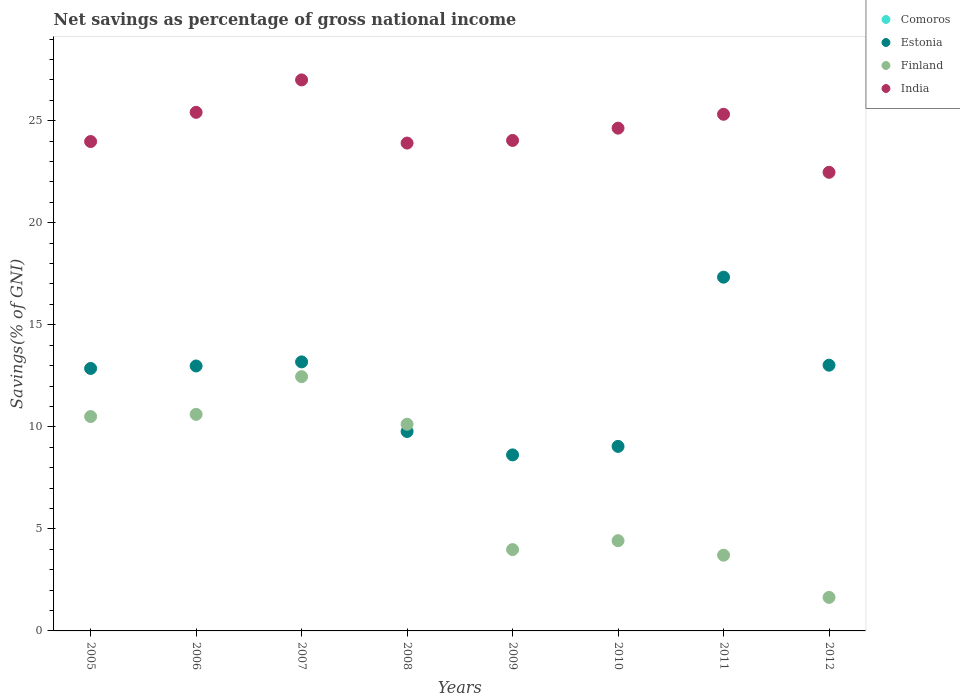How many different coloured dotlines are there?
Offer a very short reply. 3. What is the total savings in Finland in 2010?
Provide a short and direct response. 4.42. Across all years, what is the maximum total savings in Finland?
Your answer should be compact. 12.46. Across all years, what is the minimum total savings in Estonia?
Make the answer very short. 8.63. What is the total total savings in Estonia in the graph?
Give a very brief answer. 96.83. What is the difference between the total savings in India in 2005 and that in 2010?
Provide a short and direct response. -0.66. What is the difference between the total savings in Finland in 2011 and the total savings in Comoros in 2012?
Keep it short and to the point. 3.71. What is the average total savings in India per year?
Your answer should be compact. 24.6. In the year 2007, what is the difference between the total savings in Finland and total savings in India?
Your answer should be compact. -14.54. What is the ratio of the total savings in Finland in 2006 to that in 2009?
Your answer should be very brief. 2.66. Is the total savings in India in 2005 less than that in 2012?
Your answer should be compact. No. Is the difference between the total savings in Finland in 2006 and 2008 greater than the difference between the total savings in India in 2006 and 2008?
Your response must be concise. No. What is the difference between the highest and the second highest total savings in India?
Provide a succinct answer. 1.59. What is the difference between the highest and the lowest total savings in Estonia?
Your response must be concise. 8.71. Are the values on the major ticks of Y-axis written in scientific E-notation?
Give a very brief answer. No. Does the graph contain grids?
Provide a short and direct response. No. How many legend labels are there?
Give a very brief answer. 4. How are the legend labels stacked?
Make the answer very short. Vertical. What is the title of the graph?
Make the answer very short. Net savings as percentage of gross national income. Does "Namibia" appear as one of the legend labels in the graph?
Provide a short and direct response. No. What is the label or title of the Y-axis?
Keep it short and to the point. Savings(% of GNI). What is the Savings(% of GNI) in Comoros in 2005?
Provide a short and direct response. 0. What is the Savings(% of GNI) of Estonia in 2005?
Your response must be concise. 12.86. What is the Savings(% of GNI) of Finland in 2005?
Provide a short and direct response. 10.5. What is the Savings(% of GNI) of India in 2005?
Your answer should be compact. 23.98. What is the Savings(% of GNI) in Estonia in 2006?
Provide a succinct answer. 12.98. What is the Savings(% of GNI) of Finland in 2006?
Your response must be concise. 10.61. What is the Savings(% of GNI) in India in 2006?
Ensure brevity in your answer.  25.41. What is the Savings(% of GNI) in Estonia in 2007?
Your answer should be compact. 13.18. What is the Savings(% of GNI) in Finland in 2007?
Keep it short and to the point. 12.46. What is the Savings(% of GNI) in India in 2007?
Your answer should be very brief. 27. What is the Savings(% of GNI) of Comoros in 2008?
Offer a very short reply. 0. What is the Savings(% of GNI) in Estonia in 2008?
Keep it short and to the point. 9.77. What is the Savings(% of GNI) of Finland in 2008?
Offer a terse response. 10.13. What is the Savings(% of GNI) in India in 2008?
Ensure brevity in your answer.  23.91. What is the Savings(% of GNI) of Estonia in 2009?
Offer a terse response. 8.63. What is the Savings(% of GNI) of Finland in 2009?
Your answer should be very brief. 3.99. What is the Savings(% of GNI) of India in 2009?
Your response must be concise. 24.04. What is the Savings(% of GNI) of Comoros in 2010?
Make the answer very short. 0. What is the Savings(% of GNI) in Estonia in 2010?
Provide a succinct answer. 9.04. What is the Savings(% of GNI) in Finland in 2010?
Provide a short and direct response. 4.42. What is the Savings(% of GNI) of India in 2010?
Offer a very short reply. 24.64. What is the Savings(% of GNI) in Estonia in 2011?
Your answer should be compact. 17.33. What is the Savings(% of GNI) of Finland in 2011?
Your answer should be compact. 3.71. What is the Savings(% of GNI) in India in 2011?
Keep it short and to the point. 25.32. What is the Savings(% of GNI) in Comoros in 2012?
Your answer should be very brief. 0. What is the Savings(% of GNI) of Estonia in 2012?
Your answer should be very brief. 13.02. What is the Savings(% of GNI) in Finland in 2012?
Offer a terse response. 1.64. What is the Savings(% of GNI) of India in 2012?
Your answer should be very brief. 22.47. Across all years, what is the maximum Savings(% of GNI) of Estonia?
Offer a very short reply. 17.33. Across all years, what is the maximum Savings(% of GNI) in Finland?
Offer a very short reply. 12.46. Across all years, what is the maximum Savings(% of GNI) in India?
Give a very brief answer. 27. Across all years, what is the minimum Savings(% of GNI) of Estonia?
Give a very brief answer. 8.63. Across all years, what is the minimum Savings(% of GNI) in Finland?
Provide a succinct answer. 1.64. Across all years, what is the minimum Savings(% of GNI) in India?
Your response must be concise. 22.47. What is the total Savings(% of GNI) in Comoros in the graph?
Offer a terse response. 0. What is the total Savings(% of GNI) of Estonia in the graph?
Your answer should be very brief. 96.83. What is the total Savings(% of GNI) in Finland in the graph?
Provide a succinct answer. 57.47. What is the total Savings(% of GNI) in India in the graph?
Provide a succinct answer. 196.76. What is the difference between the Savings(% of GNI) of Estonia in 2005 and that in 2006?
Make the answer very short. -0.12. What is the difference between the Savings(% of GNI) of Finland in 2005 and that in 2006?
Ensure brevity in your answer.  -0.11. What is the difference between the Savings(% of GNI) of India in 2005 and that in 2006?
Offer a terse response. -1.43. What is the difference between the Savings(% of GNI) of Estonia in 2005 and that in 2007?
Your answer should be very brief. -0.32. What is the difference between the Savings(% of GNI) of Finland in 2005 and that in 2007?
Offer a very short reply. -1.95. What is the difference between the Savings(% of GNI) of India in 2005 and that in 2007?
Your answer should be very brief. -3.02. What is the difference between the Savings(% of GNI) of Estonia in 2005 and that in 2008?
Your answer should be very brief. 3.09. What is the difference between the Savings(% of GNI) of Finland in 2005 and that in 2008?
Your response must be concise. 0.38. What is the difference between the Savings(% of GNI) of India in 2005 and that in 2008?
Offer a very short reply. 0.08. What is the difference between the Savings(% of GNI) of Estonia in 2005 and that in 2009?
Ensure brevity in your answer.  4.24. What is the difference between the Savings(% of GNI) in Finland in 2005 and that in 2009?
Your answer should be very brief. 6.52. What is the difference between the Savings(% of GNI) of India in 2005 and that in 2009?
Your answer should be compact. -0.05. What is the difference between the Savings(% of GNI) in Estonia in 2005 and that in 2010?
Your answer should be compact. 3.82. What is the difference between the Savings(% of GNI) of Finland in 2005 and that in 2010?
Your response must be concise. 6.08. What is the difference between the Savings(% of GNI) of India in 2005 and that in 2010?
Offer a very short reply. -0.66. What is the difference between the Savings(% of GNI) in Estonia in 2005 and that in 2011?
Make the answer very short. -4.47. What is the difference between the Savings(% of GNI) of Finland in 2005 and that in 2011?
Your answer should be compact. 6.79. What is the difference between the Savings(% of GNI) of India in 2005 and that in 2011?
Provide a succinct answer. -1.34. What is the difference between the Savings(% of GNI) in Estonia in 2005 and that in 2012?
Ensure brevity in your answer.  -0.16. What is the difference between the Savings(% of GNI) in Finland in 2005 and that in 2012?
Make the answer very short. 8.86. What is the difference between the Savings(% of GNI) in India in 2005 and that in 2012?
Make the answer very short. 1.51. What is the difference between the Savings(% of GNI) in Estonia in 2006 and that in 2007?
Your response must be concise. -0.2. What is the difference between the Savings(% of GNI) of Finland in 2006 and that in 2007?
Provide a short and direct response. -1.85. What is the difference between the Savings(% of GNI) in India in 2006 and that in 2007?
Give a very brief answer. -1.59. What is the difference between the Savings(% of GNI) in Estonia in 2006 and that in 2008?
Make the answer very short. 3.21. What is the difference between the Savings(% of GNI) in Finland in 2006 and that in 2008?
Your answer should be very brief. 0.48. What is the difference between the Savings(% of GNI) in India in 2006 and that in 2008?
Give a very brief answer. 1.51. What is the difference between the Savings(% of GNI) in Estonia in 2006 and that in 2009?
Your answer should be compact. 4.36. What is the difference between the Savings(% of GNI) in Finland in 2006 and that in 2009?
Ensure brevity in your answer.  6.63. What is the difference between the Savings(% of GNI) of India in 2006 and that in 2009?
Offer a terse response. 1.38. What is the difference between the Savings(% of GNI) of Estonia in 2006 and that in 2010?
Your answer should be compact. 3.94. What is the difference between the Savings(% of GNI) of Finland in 2006 and that in 2010?
Offer a terse response. 6.19. What is the difference between the Savings(% of GNI) of India in 2006 and that in 2010?
Your answer should be compact. 0.78. What is the difference between the Savings(% of GNI) in Estonia in 2006 and that in 2011?
Ensure brevity in your answer.  -4.35. What is the difference between the Savings(% of GNI) of Finland in 2006 and that in 2011?
Offer a very short reply. 6.9. What is the difference between the Savings(% of GNI) of India in 2006 and that in 2011?
Ensure brevity in your answer.  0.09. What is the difference between the Savings(% of GNI) of Estonia in 2006 and that in 2012?
Your answer should be compact. -0.04. What is the difference between the Savings(% of GNI) in Finland in 2006 and that in 2012?
Provide a short and direct response. 8.97. What is the difference between the Savings(% of GNI) in India in 2006 and that in 2012?
Make the answer very short. 2.94. What is the difference between the Savings(% of GNI) in Estonia in 2007 and that in 2008?
Provide a short and direct response. 3.41. What is the difference between the Savings(% of GNI) of Finland in 2007 and that in 2008?
Offer a very short reply. 2.33. What is the difference between the Savings(% of GNI) of India in 2007 and that in 2008?
Keep it short and to the point. 3.09. What is the difference between the Savings(% of GNI) of Estonia in 2007 and that in 2009?
Your answer should be compact. 4.56. What is the difference between the Savings(% of GNI) in Finland in 2007 and that in 2009?
Offer a terse response. 8.47. What is the difference between the Savings(% of GNI) in India in 2007 and that in 2009?
Give a very brief answer. 2.97. What is the difference between the Savings(% of GNI) of Estonia in 2007 and that in 2010?
Provide a short and direct response. 4.14. What is the difference between the Savings(% of GNI) of Finland in 2007 and that in 2010?
Offer a very short reply. 8.04. What is the difference between the Savings(% of GNI) of India in 2007 and that in 2010?
Provide a short and direct response. 2.36. What is the difference between the Savings(% of GNI) of Estonia in 2007 and that in 2011?
Offer a terse response. -4.15. What is the difference between the Savings(% of GNI) of Finland in 2007 and that in 2011?
Provide a succinct answer. 8.75. What is the difference between the Savings(% of GNI) of India in 2007 and that in 2011?
Offer a terse response. 1.68. What is the difference between the Savings(% of GNI) of Estonia in 2007 and that in 2012?
Provide a short and direct response. 0.16. What is the difference between the Savings(% of GNI) in Finland in 2007 and that in 2012?
Provide a succinct answer. 10.82. What is the difference between the Savings(% of GNI) in India in 2007 and that in 2012?
Keep it short and to the point. 4.53. What is the difference between the Savings(% of GNI) of Estonia in 2008 and that in 2009?
Keep it short and to the point. 1.15. What is the difference between the Savings(% of GNI) in Finland in 2008 and that in 2009?
Offer a very short reply. 6.14. What is the difference between the Savings(% of GNI) in India in 2008 and that in 2009?
Keep it short and to the point. -0.13. What is the difference between the Savings(% of GNI) in Estonia in 2008 and that in 2010?
Keep it short and to the point. 0.73. What is the difference between the Savings(% of GNI) of Finland in 2008 and that in 2010?
Provide a short and direct response. 5.71. What is the difference between the Savings(% of GNI) in India in 2008 and that in 2010?
Give a very brief answer. -0.73. What is the difference between the Savings(% of GNI) of Estonia in 2008 and that in 2011?
Keep it short and to the point. -7.56. What is the difference between the Savings(% of GNI) of Finland in 2008 and that in 2011?
Keep it short and to the point. 6.42. What is the difference between the Savings(% of GNI) of India in 2008 and that in 2011?
Ensure brevity in your answer.  -1.41. What is the difference between the Savings(% of GNI) of Estonia in 2008 and that in 2012?
Keep it short and to the point. -3.25. What is the difference between the Savings(% of GNI) in Finland in 2008 and that in 2012?
Provide a succinct answer. 8.49. What is the difference between the Savings(% of GNI) in India in 2008 and that in 2012?
Make the answer very short. 1.43. What is the difference between the Savings(% of GNI) in Estonia in 2009 and that in 2010?
Make the answer very short. -0.42. What is the difference between the Savings(% of GNI) in Finland in 2009 and that in 2010?
Provide a short and direct response. -0.44. What is the difference between the Savings(% of GNI) of India in 2009 and that in 2010?
Your answer should be compact. -0.6. What is the difference between the Savings(% of GNI) of Estonia in 2009 and that in 2011?
Offer a terse response. -8.71. What is the difference between the Savings(% of GNI) of Finland in 2009 and that in 2011?
Your response must be concise. 0.27. What is the difference between the Savings(% of GNI) of India in 2009 and that in 2011?
Your answer should be very brief. -1.28. What is the difference between the Savings(% of GNI) in Estonia in 2009 and that in 2012?
Your answer should be compact. -4.4. What is the difference between the Savings(% of GNI) of Finland in 2009 and that in 2012?
Your answer should be compact. 2.34. What is the difference between the Savings(% of GNI) in India in 2009 and that in 2012?
Make the answer very short. 1.56. What is the difference between the Savings(% of GNI) of Estonia in 2010 and that in 2011?
Your answer should be compact. -8.29. What is the difference between the Savings(% of GNI) of Finland in 2010 and that in 2011?
Provide a short and direct response. 0.71. What is the difference between the Savings(% of GNI) in India in 2010 and that in 2011?
Provide a succinct answer. -0.68. What is the difference between the Savings(% of GNI) in Estonia in 2010 and that in 2012?
Make the answer very short. -3.98. What is the difference between the Savings(% of GNI) in Finland in 2010 and that in 2012?
Provide a short and direct response. 2.78. What is the difference between the Savings(% of GNI) in India in 2010 and that in 2012?
Your answer should be very brief. 2.16. What is the difference between the Savings(% of GNI) in Estonia in 2011 and that in 2012?
Provide a short and direct response. 4.31. What is the difference between the Savings(% of GNI) in Finland in 2011 and that in 2012?
Make the answer very short. 2.07. What is the difference between the Savings(% of GNI) in India in 2011 and that in 2012?
Provide a short and direct response. 2.84. What is the difference between the Savings(% of GNI) in Estonia in 2005 and the Savings(% of GNI) in Finland in 2006?
Your response must be concise. 2.25. What is the difference between the Savings(% of GNI) in Estonia in 2005 and the Savings(% of GNI) in India in 2006?
Ensure brevity in your answer.  -12.55. What is the difference between the Savings(% of GNI) in Finland in 2005 and the Savings(% of GNI) in India in 2006?
Your response must be concise. -14.91. What is the difference between the Savings(% of GNI) of Estonia in 2005 and the Savings(% of GNI) of Finland in 2007?
Make the answer very short. 0.4. What is the difference between the Savings(% of GNI) in Estonia in 2005 and the Savings(% of GNI) in India in 2007?
Provide a short and direct response. -14.14. What is the difference between the Savings(% of GNI) of Finland in 2005 and the Savings(% of GNI) of India in 2007?
Your response must be concise. -16.5. What is the difference between the Savings(% of GNI) in Estonia in 2005 and the Savings(% of GNI) in Finland in 2008?
Ensure brevity in your answer.  2.73. What is the difference between the Savings(% of GNI) of Estonia in 2005 and the Savings(% of GNI) of India in 2008?
Make the answer very short. -11.04. What is the difference between the Savings(% of GNI) of Finland in 2005 and the Savings(% of GNI) of India in 2008?
Give a very brief answer. -13.4. What is the difference between the Savings(% of GNI) of Estonia in 2005 and the Savings(% of GNI) of Finland in 2009?
Provide a succinct answer. 8.88. What is the difference between the Savings(% of GNI) in Estonia in 2005 and the Savings(% of GNI) in India in 2009?
Your answer should be compact. -11.17. What is the difference between the Savings(% of GNI) of Finland in 2005 and the Savings(% of GNI) of India in 2009?
Your response must be concise. -13.53. What is the difference between the Savings(% of GNI) of Estonia in 2005 and the Savings(% of GNI) of Finland in 2010?
Provide a succinct answer. 8.44. What is the difference between the Savings(% of GNI) in Estonia in 2005 and the Savings(% of GNI) in India in 2010?
Make the answer very short. -11.78. What is the difference between the Savings(% of GNI) of Finland in 2005 and the Savings(% of GNI) of India in 2010?
Offer a very short reply. -14.13. What is the difference between the Savings(% of GNI) in Estonia in 2005 and the Savings(% of GNI) in Finland in 2011?
Give a very brief answer. 9.15. What is the difference between the Savings(% of GNI) in Estonia in 2005 and the Savings(% of GNI) in India in 2011?
Give a very brief answer. -12.46. What is the difference between the Savings(% of GNI) in Finland in 2005 and the Savings(% of GNI) in India in 2011?
Your response must be concise. -14.81. What is the difference between the Savings(% of GNI) of Estonia in 2005 and the Savings(% of GNI) of Finland in 2012?
Provide a succinct answer. 11.22. What is the difference between the Savings(% of GNI) in Estonia in 2005 and the Savings(% of GNI) in India in 2012?
Offer a terse response. -9.61. What is the difference between the Savings(% of GNI) in Finland in 2005 and the Savings(% of GNI) in India in 2012?
Your answer should be very brief. -11.97. What is the difference between the Savings(% of GNI) in Estonia in 2006 and the Savings(% of GNI) in Finland in 2007?
Your response must be concise. 0.52. What is the difference between the Savings(% of GNI) of Estonia in 2006 and the Savings(% of GNI) of India in 2007?
Offer a terse response. -14.02. What is the difference between the Savings(% of GNI) in Finland in 2006 and the Savings(% of GNI) in India in 2007?
Your answer should be very brief. -16.39. What is the difference between the Savings(% of GNI) in Estonia in 2006 and the Savings(% of GNI) in Finland in 2008?
Provide a succinct answer. 2.85. What is the difference between the Savings(% of GNI) in Estonia in 2006 and the Savings(% of GNI) in India in 2008?
Your response must be concise. -10.92. What is the difference between the Savings(% of GNI) in Finland in 2006 and the Savings(% of GNI) in India in 2008?
Keep it short and to the point. -13.29. What is the difference between the Savings(% of GNI) in Estonia in 2006 and the Savings(% of GNI) in Finland in 2009?
Offer a very short reply. 9. What is the difference between the Savings(% of GNI) of Estonia in 2006 and the Savings(% of GNI) of India in 2009?
Provide a succinct answer. -11.05. What is the difference between the Savings(% of GNI) in Finland in 2006 and the Savings(% of GNI) in India in 2009?
Your answer should be very brief. -13.42. What is the difference between the Savings(% of GNI) of Estonia in 2006 and the Savings(% of GNI) of Finland in 2010?
Your answer should be very brief. 8.56. What is the difference between the Savings(% of GNI) of Estonia in 2006 and the Savings(% of GNI) of India in 2010?
Your answer should be compact. -11.65. What is the difference between the Savings(% of GNI) of Finland in 2006 and the Savings(% of GNI) of India in 2010?
Provide a short and direct response. -14.02. What is the difference between the Savings(% of GNI) of Estonia in 2006 and the Savings(% of GNI) of Finland in 2011?
Ensure brevity in your answer.  9.27. What is the difference between the Savings(% of GNI) in Estonia in 2006 and the Savings(% of GNI) in India in 2011?
Keep it short and to the point. -12.33. What is the difference between the Savings(% of GNI) of Finland in 2006 and the Savings(% of GNI) of India in 2011?
Give a very brief answer. -14.7. What is the difference between the Savings(% of GNI) of Estonia in 2006 and the Savings(% of GNI) of Finland in 2012?
Your answer should be compact. 11.34. What is the difference between the Savings(% of GNI) in Estonia in 2006 and the Savings(% of GNI) in India in 2012?
Give a very brief answer. -9.49. What is the difference between the Savings(% of GNI) of Finland in 2006 and the Savings(% of GNI) of India in 2012?
Ensure brevity in your answer.  -11.86. What is the difference between the Savings(% of GNI) in Estonia in 2007 and the Savings(% of GNI) in Finland in 2008?
Provide a short and direct response. 3.05. What is the difference between the Savings(% of GNI) in Estonia in 2007 and the Savings(% of GNI) in India in 2008?
Provide a succinct answer. -10.72. What is the difference between the Savings(% of GNI) of Finland in 2007 and the Savings(% of GNI) of India in 2008?
Keep it short and to the point. -11.45. What is the difference between the Savings(% of GNI) of Estonia in 2007 and the Savings(% of GNI) of Finland in 2009?
Provide a short and direct response. 9.2. What is the difference between the Savings(% of GNI) of Estonia in 2007 and the Savings(% of GNI) of India in 2009?
Your answer should be compact. -10.85. What is the difference between the Savings(% of GNI) in Finland in 2007 and the Savings(% of GNI) in India in 2009?
Your response must be concise. -11.58. What is the difference between the Savings(% of GNI) of Estonia in 2007 and the Savings(% of GNI) of Finland in 2010?
Offer a very short reply. 8.76. What is the difference between the Savings(% of GNI) of Estonia in 2007 and the Savings(% of GNI) of India in 2010?
Ensure brevity in your answer.  -11.45. What is the difference between the Savings(% of GNI) of Finland in 2007 and the Savings(% of GNI) of India in 2010?
Provide a succinct answer. -12.18. What is the difference between the Savings(% of GNI) of Estonia in 2007 and the Savings(% of GNI) of Finland in 2011?
Keep it short and to the point. 9.47. What is the difference between the Savings(% of GNI) in Estonia in 2007 and the Savings(% of GNI) in India in 2011?
Your answer should be compact. -12.13. What is the difference between the Savings(% of GNI) of Finland in 2007 and the Savings(% of GNI) of India in 2011?
Offer a terse response. -12.86. What is the difference between the Savings(% of GNI) in Estonia in 2007 and the Savings(% of GNI) in Finland in 2012?
Your answer should be very brief. 11.54. What is the difference between the Savings(% of GNI) in Estonia in 2007 and the Savings(% of GNI) in India in 2012?
Your answer should be compact. -9.29. What is the difference between the Savings(% of GNI) in Finland in 2007 and the Savings(% of GNI) in India in 2012?
Give a very brief answer. -10.01. What is the difference between the Savings(% of GNI) of Estonia in 2008 and the Savings(% of GNI) of Finland in 2009?
Make the answer very short. 5.79. What is the difference between the Savings(% of GNI) in Estonia in 2008 and the Savings(% of GNI) in India in 2009?
Your answer should be very brief. -14.26. What is the difference between the Savings(% of GNI) of Finland in 2008 and the Savings(% of GNI) of India in 2009?
Your response must be concise. -13.91. What is the difference between the Savings(% of GNI) in Estonia in 2008 and the Savings(% of GNI) in Finland in 2010?
Your answer should be compact. 5.35. What is the difference between the Savings(% of GNI) of Estonia in 2008 and the Savings(% of GNI) of India in 2010?
Provide a short and direct response. -14.86. What is the difference between the Savings(% of GNI) in Finland in 2008 and the Savings(% of GNI) in India in 2010?
Provide a succinct answer. -14.51. What is the difference between the Savings(% of GNI) in Estonia in 2008 and the Savings(% of GNI) in Finland in 2011?
Make the answer very short. 6.06. What is the difference between the Savings(% of GNI) in Estonia in 2008 and the Savings(% of GNI) in India in 2011?
Provide a succinct answer. -15.54. What is the difference between the Savings(% of GNI) of Finland in 2008 and the Savings(% of GNI) of India in 2011?
Your answer should be compact. -15.19. What is the difference between the Savings(% of GNI) of Estonia in 2008 and the Savings(% of GNI) of Finland in 2012?
Offer a very short reply. 8.13. What is the difference between the Savings(% of GNI) in Estonia in 2008 and the Savings(% of GNI) in India in 2012?
Give a very brief answer. -12.7. What is the difference between the Savings(% of GNI) of Finland in 2008 and the Savings(% of GNI) of India in 2012?
Provide a succinct answer. -12.34. What is the difference between the Savings(% of GNI) in Estonia in 2009 and the Savings(% of GNI) in Finland in 2010?
Your answer should be compact. 4.21. What is the difference between the Savings(% of GNI) in Estonia in 2009 and the Savings(% of GNI) in India in 2010?
Your response must be concise. -16.01. What is the difference between the Savings(% of GNI) of Finland in 2009 and the Savings(% of GNI) of India in 2010?
Offer a terse response. -20.65. What is the difference between the Savings(% of GNI) in Estonia in 2009 and the Savings(% of GNI) in Finland in 2011?
Your response must be concise. 4.91. What is the difference between the Savings(% of GNI) in Estonia in 2009 and the Savings(% of GNI) in India in 2011?
Your answer should be very brief. -16.69. What is the difference between the Savings(% of GNI) in Finland in 2009 and the Savings(% of GNI) in India in 2011?
Give a very brief answer. -21.33. What is the difference between the Savings(% of GNI) in Estonia in 2009 and the Savings(% of GNI) in Finland in 2012?
Your answer should be very brief. 6.98. What is the difference between the Savings(% of GNI) in Estonia in 2009 and the Savings(% of GNI) in India in 2012?
Your answer should be very brief. -13.85. What is the difference between the Savings(% of GNI) in Finland in 2009 and the Savings(% of GNI) in India in 2012?
Keep it short and to the point. -18.49. What is the difference between the Savings(% of GNI) in Estonia in 2010 and the Savings(% of GNI) in Finland in 2011?
Provide a succinct answer. 5.33. What is the difference between the Savings(% of GNI) in Estonia in 2010 and the Savings(% of GNI) in India in 2011?
Offer a terse response. -16.27. What is the difference between the Savings(% of GNI) in Finland in 2010 and the Savings(% of GNI) in India in 2011?
Your answer should be compact. -20.9. What is the difference between the Savings(% of GNI) of Estonia in 2010 and the Savings(% of GNI) of Finland in 2012?
Your response must be concise. 7.4. What is the difference between the Savings(% of GNI) in Estonia in 2010 and the Savings(% of GNI) in India in 2012?
Make the answer very short. -13.43. What is the difference between the Savings(% of GNI) in Finland in 2010 and the Savings(% of GNI) in India in 2012?
Give a very brief answer. -18.05. What is the difference between the Savings(% of GNI) of Estonia in 2011 and the Savings(% of GNI) of Finland in 2012?
Offer a very short reply. 15.69. What is the difference between the Savings(% of GNI) of Estonia in 2011 and the Savings(% of GNI) of India in 2012?
Give a very brief answer. -5.14. What is the difference between the Savings(% of GNI) of Finland in 2011 and the Savings(% of GNI) of India in 2012?
Provide a succinct answer. -18.76. What is the average Savings(% of GNI) in Comoros per year?
Give a very brief answer. 0. What is the average Savings(% of GNI) of Estonia per year?
Provide a succinct answer. 12.1. What is the average Savings(% of GNI) of Finland per year?
Your answer should be very brief. 7.18. What is the average Savings(% of GNI) of India per year?
Make the answer very short. 24.6. In the year 2005, what is the difference between the Savings(% of GNI) in Estonia and Savings(% of GNI) in Finland?
Give a very brief answer. 2.36. In the year 2005, what is the difference between the Savings(% of GNI) of Estonia and Savings(% of GNI) of India?
Offer a terse response. -11.12. In the year 2005, what is the difference between the Savings(% of GNI) in Finland and Savings(% of GNI) in India?
Ensure brevity in your answer.  -13.48. In the year 2006, what is the difference between the Savings(% of GNI) in Estonia and Savings(% of GNI) in Finland?
Offer a very short reply. 2.37. In the year 2006, what is the difference between the Savings(% of GNI) in Estonia and Savings(% of GNI) in India?
Ensure brevity in your answer.  -12.43. In the year 2006, what is the difference between the Savings(% of GNI) of Finland and Savings(% of GNI) of India?
Ensure brevity in your answer.  -14.8. In the year 2007, what is the difference between the Savings(% of GNI) in Estonia and Savings(% of GNI) in Finland?
Ensure brevity in your answer.  0.72. In the year 2007, what is the difference between the Savings(% of GNI) in Estonia and Savings(% of GNI) in India?
Ensure brevity in your answer.  -13.82. In the year 2007, what is the difference between the Savings(% of GNI) in Finland and Savings(% of GNI) in India?
Keep it short and to the point. -14.54. In the year 2008, what is the difference between the Savings(% of GNI) of Estonia and Savings(% of GNI) of Finland?
Give a very brief answer. -0.36. In the year 2008, what is the difference between the Savings(% of GNI) of Estonia and Savings(% of GNI) of India?
Your answer should be very brief. -14.13. In the year 2008, what is the difference between the Savings(% of GNI) in Finland and Savings(% of GNI) in India?
Your response must be concise. -13.78. In the year 2009, what is the difference between the Savings(% of GNI) in Estonia and Savings(% of GNI) in Finland?
Your answer should be very brief. 4.64. In the year 2009, what is the difference between the Savings(% of GNI) in Estonia and Savings(% of GNI) in India?
Your response must be concise. -15.41. In the year 2009, what is the difference between the Savings(% of GNI) of Finland and Savings(% of GNI) of India?
Offer a terse response. -20.05. In the year 2010, what is the difference between the Savings(% of GNI) in Estonia and Savings(% of GNI) in Finland?
Make the answer very short. 4.62. In the year 2010, what is the difference between the Savings(% of GNI) of Estonia and Savings(% of GNI) of India?
Your answer should be very brief. -15.59. In the year 2010, what is the difference between the Savings(% of GNI) in Finland and Savings(% of GNI) in India?
Offer a terse response. -20.22. In the year 2011, what is the difference between the Savings(% of GNI) in Estonia and Savings(% of GNI) in Finland?
Your answer should be compact. 13.62. In the year 2011, what is the difference between the Savings(% of GNI) in Estonia and Savings(% of GNI) in India?
Provide a short and direct response. -7.98. In the year 2011, what is the difference between the Savings(% of GNI) of Finland and Savings(% of GNI) of India?
Keep it short and to the point. -21.61. In the year 2012, what is the difference between the Savings(% of GNI) in Estonia and Savings(% of GNI) in Finland?
Offer a very short reply. 11.38. In the year 2012, what is the difference between the Savings(% of GNI) in Estonia and Savings(% of GNI) in India?
Make the answer very short. -9.45. In the year 2012, what is the difference between the Savings(% of GNI) in Finland and Savings(% of GNI) in India?
Offer a terse response. -20.83. What is the ratio of the Savings(% of GNI) of Finland in 2005 to that in 2006?
Keep it short and to the point. 0.99. What is the ratio of the Savings(% of GNI) of India in 2005 to that in 2006?
Your answer should be compact. 0.94. What is the ratio of the Savings(% of GNI) of Estonia in 2005 to that in 2007?
Ensure brevity in your answer.  0.98. What is the ratio of the Savings(% of GNI) in Finland in 2005 to that in 2007?
Offer a terse response. 0.84. What is the ratio of the Savings(% of GNI) of India in 2005 to that in 2007?
Ensure brevity in your answer.  0.89. What is the ratio of the Savings(% of GNI) of Estonia in 2005 to that in 2008?
Offer a very short reply. 1.32. What is the ratio of the Savings(% of GNI) of Finland in 2005 to that in 2008?
Keep it short and to the point. 1.04. What is the ratio of the Savings(% of GNI) of India in 2005 to that in 2008?
Make the answer very short. 1. What is the ratio of the Savings(% of GNI) of Estonia in 2005 to that in 2009?
Your answer should be very brief. 1.49. What is the ratio of the Savings(% of GNI) in Finland in 2005 to that in 2009?
Provide a succinct answer. 2.64. What is the ratio of the Savings(% of GNI) of Estonia in 2005 to that in 2010?
Keep it short and to the point. 1.42. What is the ratio of the Savings(% of GNI) in Finland in 2005 to that in 2010?
Give a very brief answer. 2.38. What is the ratio of the Savings(% of GNI) in India in 2005 to that in 2010?
Keep it short and to the point. 0.97. What is the ratio of the Savings(% of GNI) of Estonia in 2005 to that in 2011?
Ensure brevity in your answer.  0.74. What is the ratio of the Savings(% of GNI) of Finland in 2005 to that in 2011?
Offer a terse response. 2.83. What is the ratio of the Savings(% of GNI) of India in 2005 to that in 2011?
Your answer should be very brief. 0.95. What is the ratio of the Savings(% of GNI) in Estonia in 2005 to that in 2012?
Offer a very short reply. 0.99. What is the ratio of the Savings(% of GNI) of Finland in 2005 to that in 2012?
Your answer should be compact. 6.39. What is the ratio of the Savings(% of GNI) in India in 2005 to that in 2012?
Offer a very short reply. 1.07. What is the ratio of the Savings(% of GNI) of Estonia in 2006 to that in 2007?
Give a very brief answer. 0.98. What is the ratio of the Savings(% of GNI) in Finland in 2006 to that in 2007?
Your response must be concise. 0.85. What is the ratio of the Savings(% of GNI) in India in 2006 to that in 2007?
Your response must be concise. 0.94. What is the ratio of the Savings(% of GNI) of Estonia in 2006 to that in 2008?
Make the answer very short. 1.33. What is the ratio of the Savings(% of GNI) in Finland in 2006 to that in 2008?
Provide a short and direct response. 1.05. What is the ratio of the Savings(% of GNI) of India in 2006 to that in 2008?
Provide a succinct answer. 1.06. What is the ratio of the Savings(% of GNI) in Estonia in 2006 to that in 2009?
Ensure brevity in your answer.  1.51. What is the ratio of the Savings(% of GNI) in Finland in 2006 to that in 2009?
Make the answer very short. 2.66. What is the ratio of the Savings(% of GNI) of India in 2006 to that in 2009?
Your response must be concise. 1.06. What is the ratio of the Savings(% of GNI) of Estonia in 2006 to that in 2010?
Your answer should be very brief. 1.44. What is the ratio of the Savings(% of GNI) of Finland in 2006 to that in 2010?
Keep it short and to the point. 2.4. What is the ratio of the Savings(% of GNI) of India in 2006 to that in 2010?
Your response must be concise. 1.03. What is the ratio of the Savings(% of GNI) of Estonia in 2006 to that in 2011?
Offer a terse response. 0.75. What is the ratio of the Savings(% of GNI) of Finland in 2006 to that in 2011?
Make the answer very short. 2.86. What is the ratio of the Savings(% of GNI) in Estonia in 2006 to that in 2012?
Provide a succinct answer. 1. What is the ratio of the Savings(% of GNI) in Finland in 2006 to that in 2012?
Keep it short and to the point. 6.46. What is the ratio of the Savings(% of GNI) of India in 2006 to that in 2012?
Ensure brevity in your answer.  1.13. What is the ratio of the Savings(% of GNI) of Estonia in 2007 to that in 2008?
Ensure brevity in your answer.  1.35. What is the ratio of the Savings(% of GNI) of Finland in 2007 to that in 2008?
Give a very brief answer. 1.23. What is the ratio of the Savings(% of GNI) in India in 2007 to that in 2008?
Keep it short and to the point. 1.13. What is the ratio of the Savings(% of GNI) in Estonia in 2007 to that in 2009?
Your response must be concise. 1.53. What is the ratio of the Savings(% of GNI) in Finland in 2007 to that in 2009?
Keep it short and to the point. 3.13. What is the ratio of the Savings(% of GNI) in India in 2007 to that in 2009?
Provide a short and direct response. 1.12. What is the ratio of the Savings(% of GNI) of Estonia in 2007 to that in 2010?
Ensure brevity in your answer.  1.46. What is the ratio of the Savings(% of GNI) in Finland in 2007 to that in 2010?
Your answer should be compact. 2.82. What is the ratio of the Savings(% of GNI) of India in 2007 to that in 2010?
Your response must be concise. 1.1. What is the ratio of the Savings(% of GNI) in Estonia in 2007 to that in 2011?
Give a very brief answer. 0.76. What is the ratio of the Savings(% of GNI) in Finland in 2007 to that in 2011?
Provide a succinct answer. 3.36. What is the ratio of the Savings(% of GNI) of India in 2007 to that in 2011?
Provide a succinct answer. 1.07. What is the ratio of the Savings(% of GNI) in Estonia in 2007 to that in 2012?
Keep it short and to the point. 1.01. What is the ratio of the Savings(% of GNI) of Finland in 2007 to that in 2012?
Your answer should be compact. 7.58. What is the ratio of the Savings(% of GNI) in India in 2007 to that in 2012?
Give a very brief answer. 1.2. What is the ratio of the Savings(% of GNI) of Estonia in 2008 to that in 2009?
Keep it short and to the point. 1.13. What is the ratio of the Savings(% of GNI) in Finland in 2008 to that in 2009?
Your answer should be compact. 2.54. What is the ratio of the Savings(% of GNI) of India in 2008 to that in 2009?
Provide a succinct answer. 0.99. What is the ratio of the Savings(% of GNI) in Estonia in 2008 to that in 2010?
Ensure brevity in your answer.  1.08. What is the ratio of the Savings(% of GNI) of Finland in 2008 to that in 2010?
Make the answer very short. 2.29. What is the ratio of the Savings(% of GNI) of India in 2008 to that in 2010?
Your answer should be compact. 0.97. What is the ratio of the Savings(% of GNI) in Estonia in 2008 to that in 2011?
Ensure brevity in your answer.  0.56. What is the ratio of the Savings(% of GNI) of Finland in 2008 to that in 2011?
Ensure brevity in your answer.  2.73. What is the ratio of the Savings(% of GNI) of India in 2008 to that in 2011?
Offer a very short reply. 0.94. What is the ratio of the Savings(% of GNI) in Estonia in 2008 to that in 2012?
Offer a very short reply. 0.75. What is the ratio of the Savings(% of GNI) in Finland in 2008 to that in 2012?
Your response must be concise. 6.16. What is the ratio of the Savings(% of GNI) of India in 2008 to that in 2012?
Provide a short and direct response. 1.06. What is the ratio of the Savings(% of GNI) of Estonia in 2009 to that in 2010?
Ensure brevity in your answer.  0.95. What is the ratio of the Savings(% of GNI) in Finland in 2009 to that in 2010?
Provide a short and direct response. 0.9. What is the ratio of the Savings(% of GNI) of India in 2009 to that in 2010?
Provide a short and direct response. 0.98. What is the ratio of the Savings(% of GNI) of Estonia in 2009 to that in 2011?
Your answer should be very brief. 0.5. What is the ratio of the Savings(% of GNI) of Finland in 2009 to that in 2011?
Your answer should be very brief. 1.07. What is the ratio of the Savings(% of GNI) in India in 2009 to that in 2011?
Your response must be concise. 0.95. What is the ratio of the Savings(% of GNI) of Estonia in 2009 to that in 2012?
Provide a short and direct response. 0.66. What is the ratio of the Savings(% of GNI) in Finland in 2009 to that in 2012?
Your response must be concise. 2.43. What is the ratio of the Savings(% of GNI) in India in 2009 to that in 2012?
Offer a terse response. 1.07. What is the ratio of the Savings(% of GNI) in Estonia in 2010 to that in 2011?
Your answer should be very brief. 0.52. What is the ratio of the Savings(% of GNI) in Finland in 2010 to that in 2011?
Offer a very short reply. 1.19. What is the ratio of the Savings(% of GNI) in India in 2010 to that in 2011?
Provide a succinct answer. 0.97. What is the ratio of the Savings(% of GNI) of Estonia in 2010 to that in 2012?
Make the answer very short. 0.69. What is the ratio of the Savings(% of GNI) in Finland in 2010 to that in 2012?
Offer a terse response. 2.69. What is the ratio of the Savings(% of GNI) of India in 2010 to that in 2012?
Provide a short and direct response. 1.1. What is the ratio of the Savings(% of GNI) of Estonia in 2011 to that in 2012?
Offer a terse response. 1.33. What is the ratio of the Savings(% of GNI) in Finland in 2011 to that in 2012?
Your answer should be very brief. 2.26. What is the ratio of the Savings(% of GNI) of India in 2011 to that in 2012?
Give a very brief answer. 1.13. What is the difference between the highest and the second highest Savings(% of GNI) of Estonia?
Your answer should be very brief. 4.15. What is the difference between the highest and the second highest Savings(% of GNI) of Finland?
Offer a very short reply. 1.85. What is the difference between the highest and the second highest Savings(% of GNI) of India?
Offer a terse response. 1.59. What is the difference between the highest and the lowest Savings(% of GNI) of Estonia?
Ensure brevity in your answer.  8.71. What is the difference between the highest and the lowest Savings(% of GNI) of Finland?
Your answer should be compact. 10.82. What is the difference between the highest and the lowest Savings(% of GNI) in India?
Offer a very short reply. 4.53. 